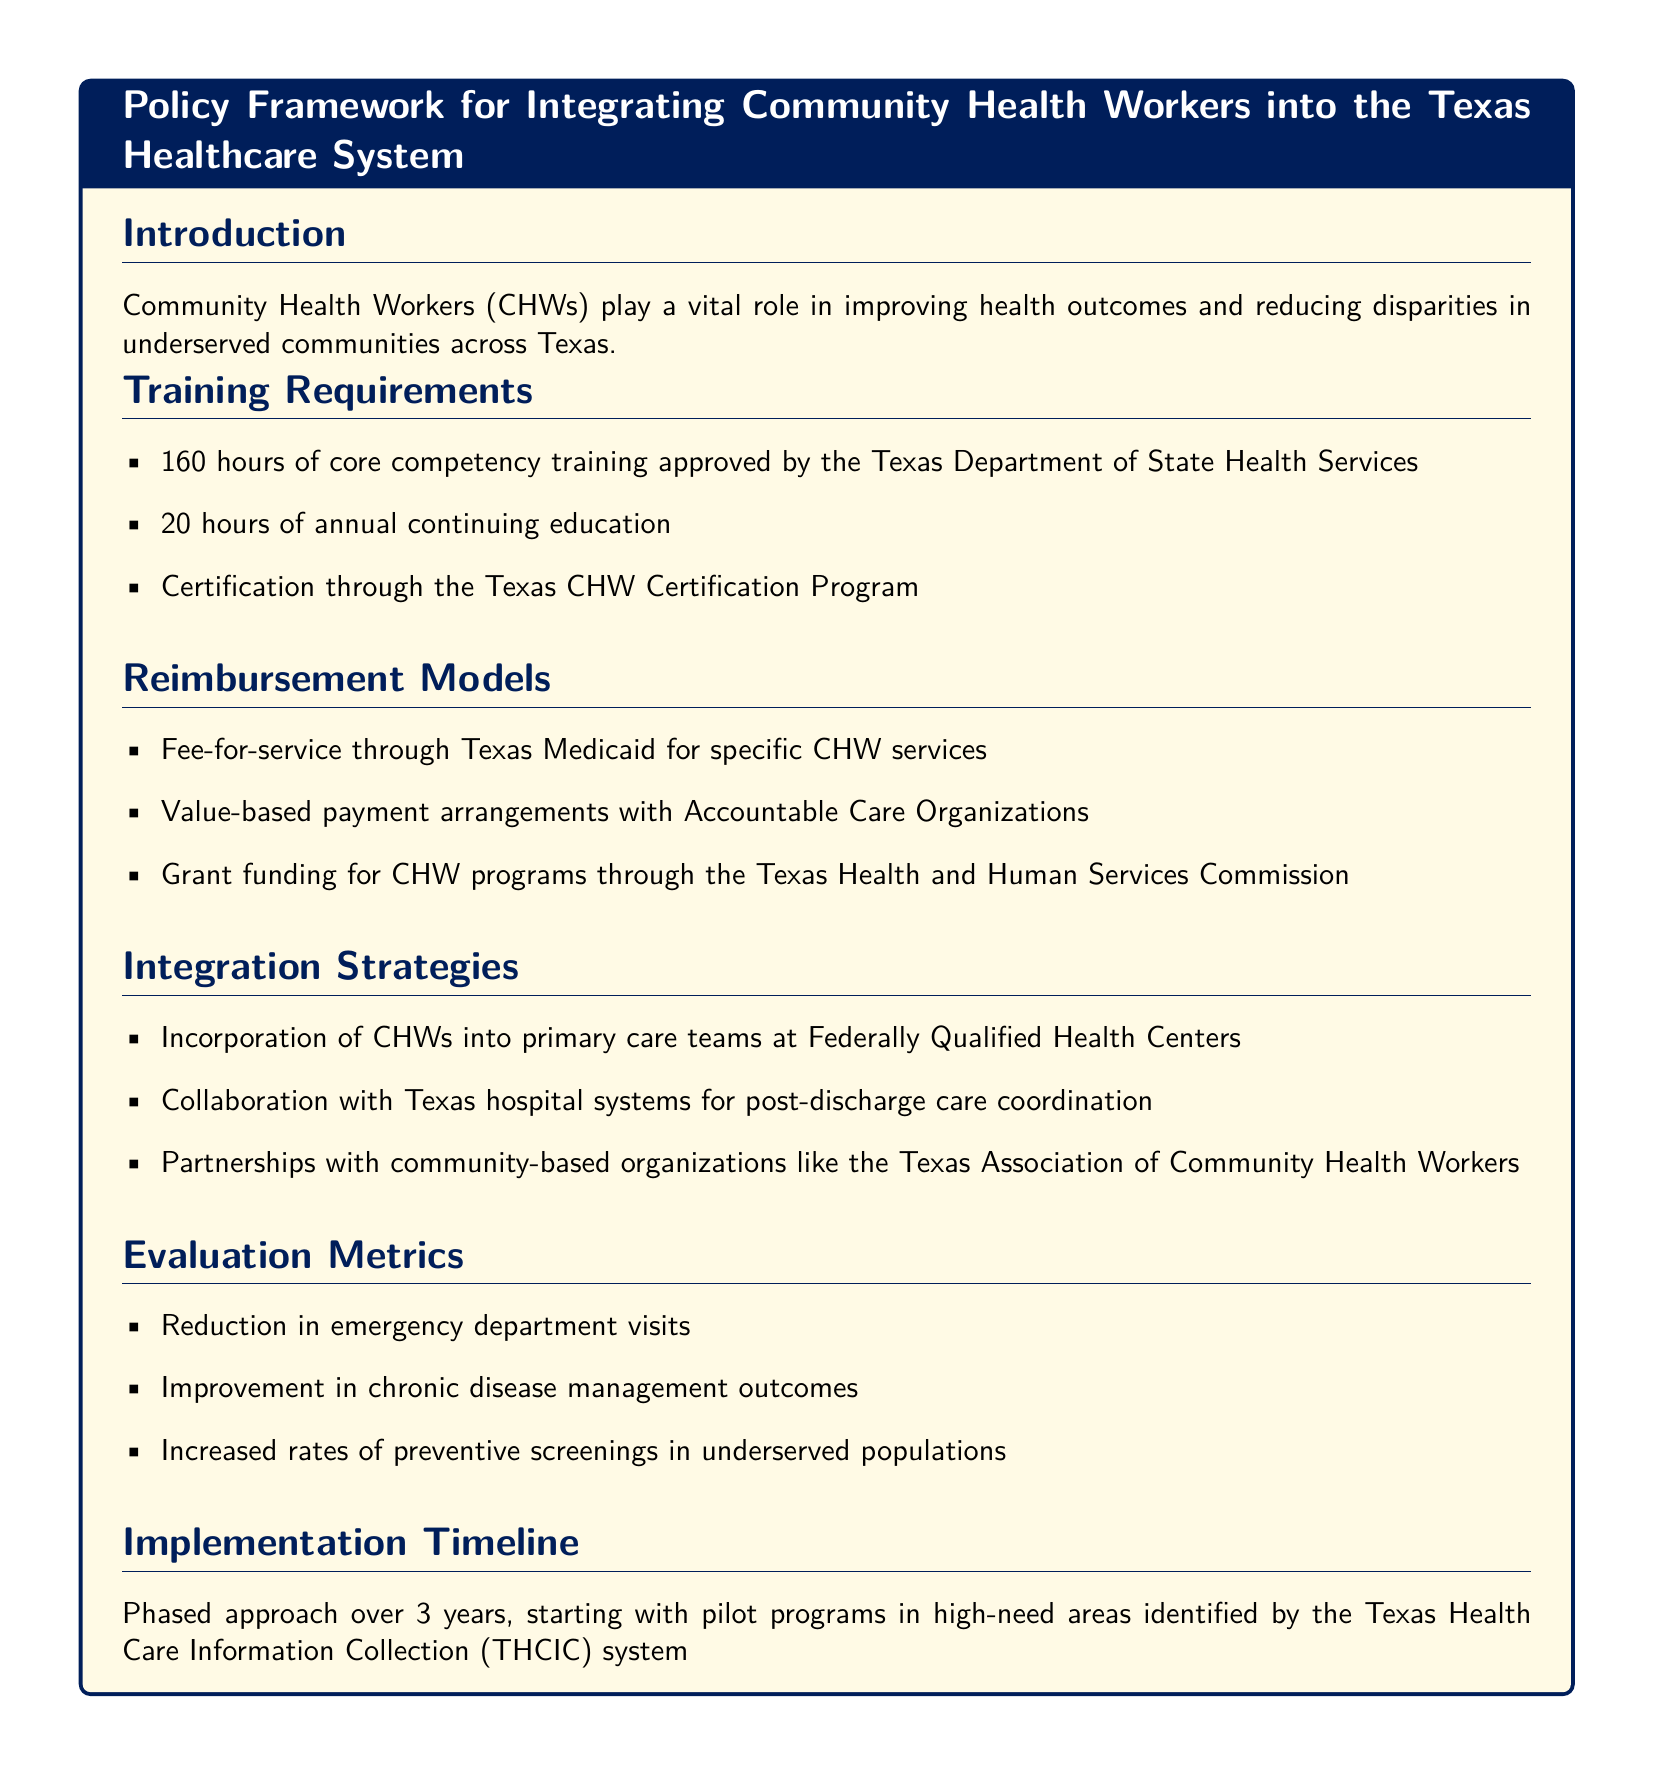What is the total number of hours for core competency training? The document states that the core competency training requires a total of 160 hours.
Answer: 160 hours Who approves the training requirements for CHWs? The training requirements for CHWs are approved by the Texas Department of State Health Services.
Answer: Texas Department of State Health Services What type of payment model is used for CHW services through Texas Medicaid? The document mentions that CHWs can be reimbursed through a fee-for-service payment model for specific services.
Answer: Fee-for-service What is one of the evaluation metrics listed in the document? The document lists multiple evaluation metrics, one of which is the reduction in emergency department visits.
Answer: Reduction in emergency department visits How many hours of continuing education are required annually for CHWs? According to the document, CHWs are required to complete 20 hours of annual continuing education.
Answer: 20 hours What is the implementation timeline mentioned in the document? The implementation timeline is described as a phased approach over 3 years, starting with pilot programs.
Answer: 3 years Which community-based organization is mentioned for partnerships in the integration strategies? The document specifies partnerships with the Texas Association of Community Health Workers.
Answer: Texas Association of Community Health Workers What is the purpose of integrating CHWs into primary care teams? The document states that integrating CHWs into primary care teams is part of the integration strategies to improve healthcare access and outcomes.
Answer: Improve healthcare access and outcomes 